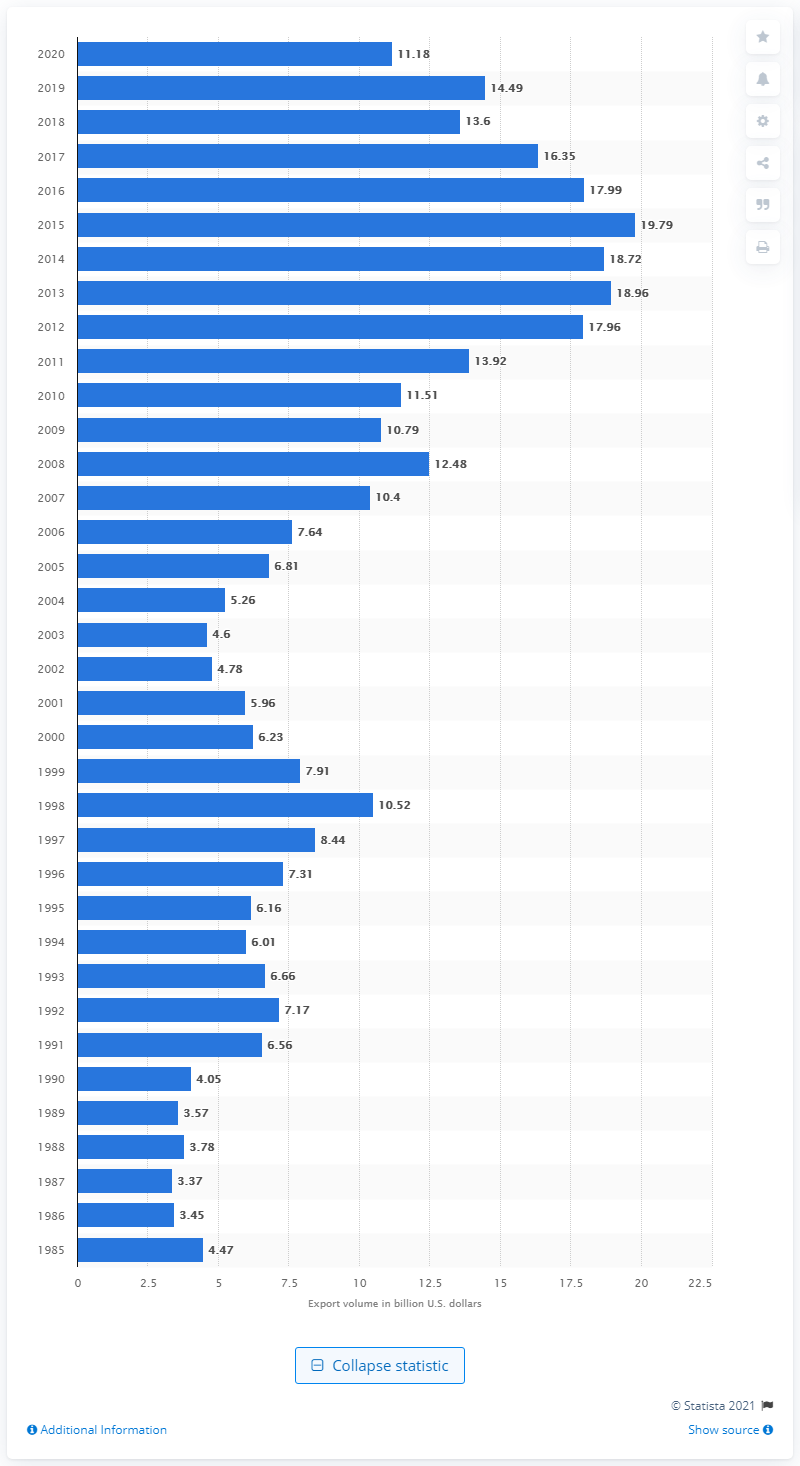Indicate a few pertinent items in this graphic. In 2020, the United States exported $11.18 billion dollars worth of goods to Saudi Arabia. 